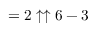<formula> <loc_0><loc_0><loc_500><loc_500>= 2 \uparrow \uparrow 6 - 3</formula> 